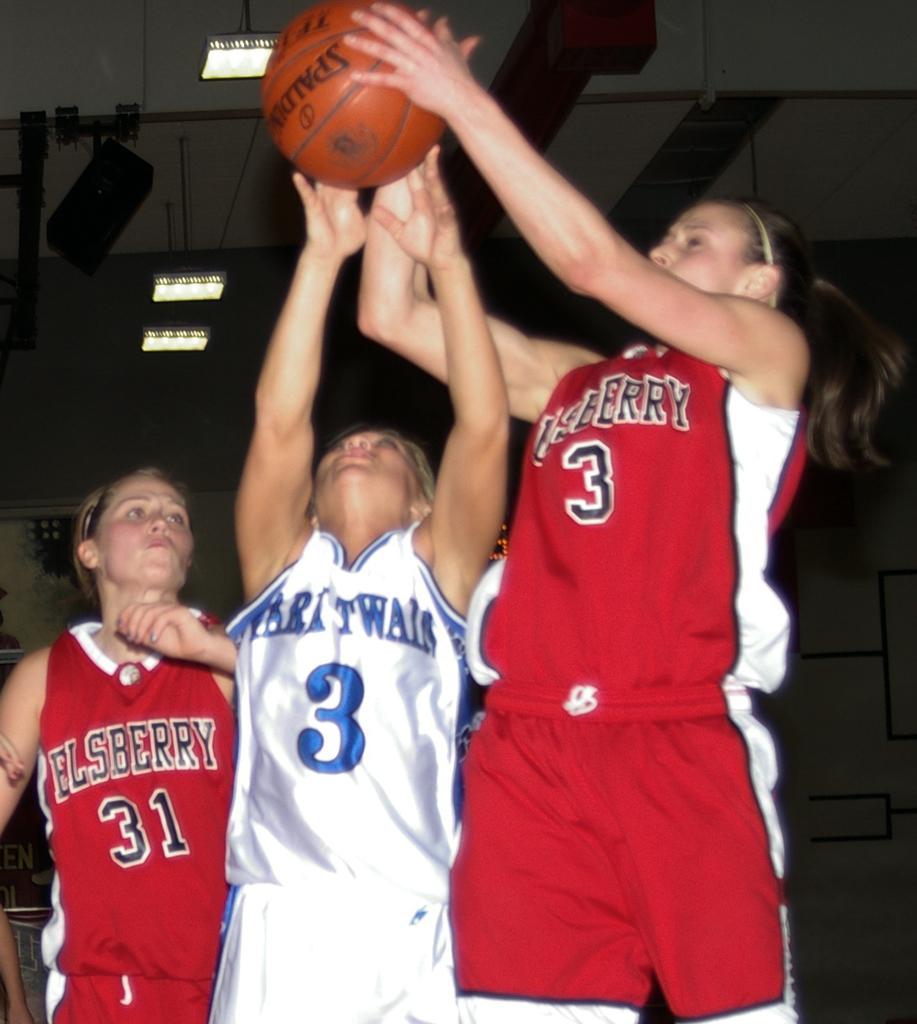What is the number of the player on the far left?
Your answer should be compact. 31. 